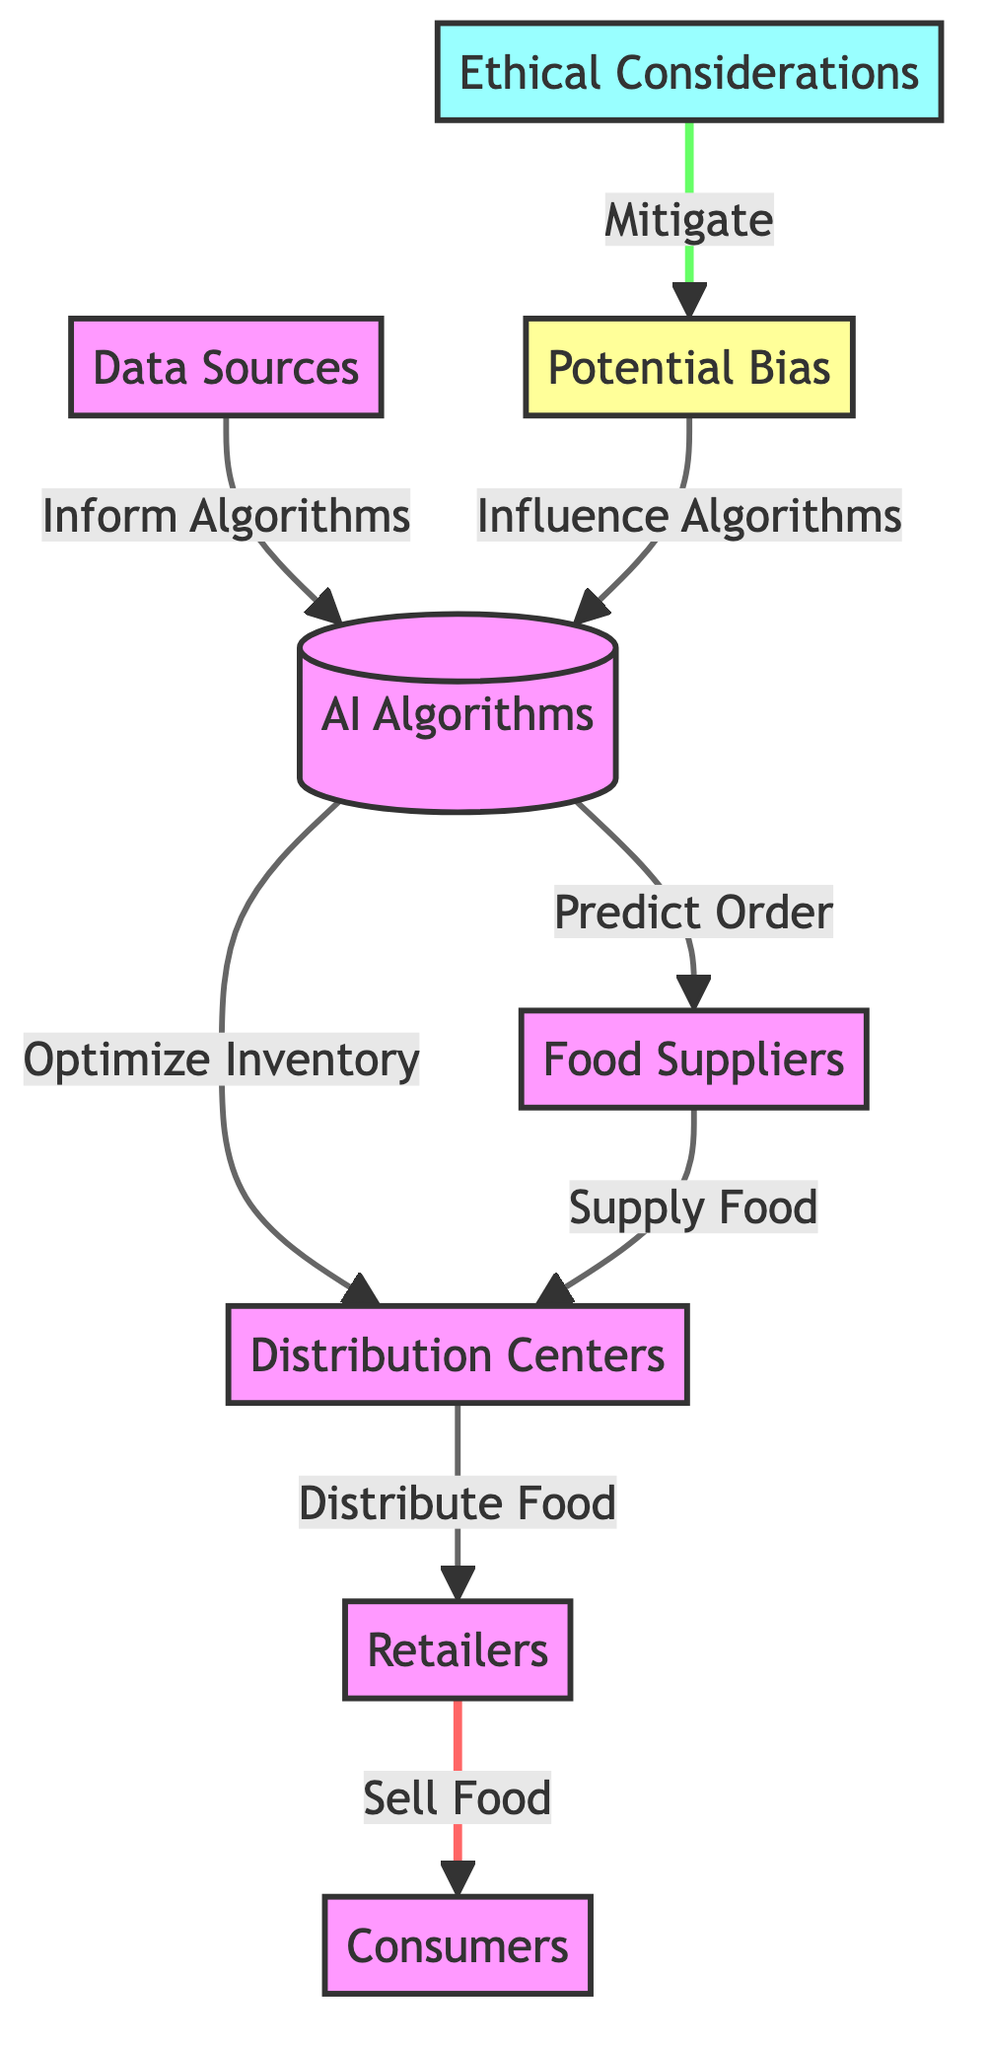What are the main nodes in this food chain diagram? The diagram has six main nodes: AI Algorithms, Data Sources, Food Suppliers, Distribution Centers, Retailers, and Consumers. Each node represents a key component of the food distribution process.
Answer: AI Algorithms, Data Sources, Food Suppliers, Distribution Centers, Retailers, Consumers How many edges are present in the diagram? By counting the connections between the nodes, we find that there are a total of six edges in the diagram, illustrating how information flows between the different components.
Answer: Six Which node receives information directly from Data Sources? The AI Algorithms node receives information from Data Sources, which informs the predictive and optimization processes.
Answer: AI Algorithms What action is taken by Food Suppliers as per the diagram? According to the diagram, Food Suppliers are responsible for supplying food to Distribution Centers, establishing a supply chain link.
Answer: Supply Food How does Potential Bias influence AI Algorithms? Potential Bias influences AI Algorithms by affecting their predictive capabilities and decision-making processes, highlighting the risk of bias in AI systems.
Answer: Influence Algorithms What is the role of Ethical Considerations in relation to Potential Bias? Ethical Considerations are intended to mitigate Potential Bias, suggesting that ethical frameworks are needed to address biases inherent in AI-driven systems in food distribution.
Answer: Mitigate Which node connects Retailers to Consumers? The diagram illustrates that Retailers connect to Consumers by selling food, completing the distribution chain from production to consumption.
Answer: Sell Food What is the relationship between Distribution Centers and Food Suppliers in this diagram? Distribution Centers receive food from Food Suppliers, indicating a direct supply chain interaction that is crucial for food logistics.
Answer: Supply Food What is the action that AI Algorithms perform regarding inventory? AI Algorithms optimize inventory, ensuring that resources are efficiently managed within the food distribution process.
Answer: Optimize Inventory 